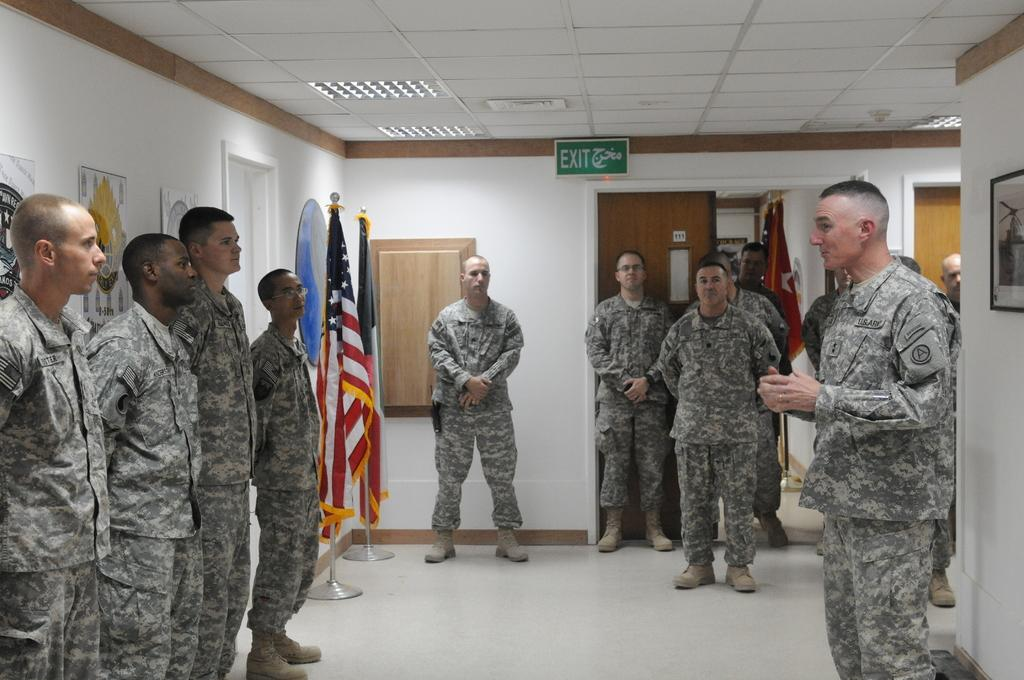What are the people in the image doing? The people in the image are standing near the walls. What can be seen on the wall in the image? There are photo frames on the wall. What other objects are present in the image? There are flags in the image. What is visible above the people in the image? There is a ceiling visible in the image. What can be seen on the ceiling? There are lights on the ceiling. Is there any evidence of hate or animosity between the people in the image? There is no indication of hate or animosity between the people in the image; they are simply standing near the walls. Can you see any icicles hanging from the ceiling in the image? There are no icicles visible in the image; the focus is on the people, photo frames, flags, ceiling, and lights. 